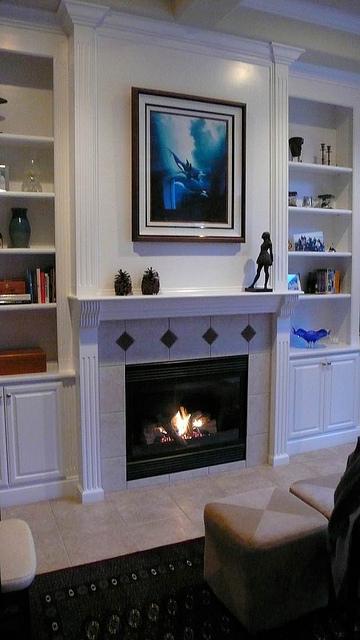Is the fireplace useable?
Answer briefly. Yes. Why are there no cabinet doors on the right side?
Concise answer only. It's shelf. Does the person who lives in this room read a lot?
Give a very brief answer. No. What is at the bottom of the picture?
Keep it brief. Rug. Is there a photo on the wall?
Write a very short answer. Yes. How many women are in the picture?
Keep it brief. 0. How many license plates are on the shelves?
Write a very short answer. 0. What kind of room is this?
Write a very short answer. Living room. What material is the fireplace made out of?
Concise answer only. Wood. Is there a lump next to the fireplace?
Short answer required. No. Who is on the poster between the bookshelves?
Concise answer only. Bird. How many red books are there?
Write a very short answer. 1. Is the fireplace lit?
Answer briefly. Yes. Where is the painting?
Give a very brief answer. Above fireplace. What is covering the window?
Be succinct. Nothing. Was someone/something resting on the ottoman?
Short answer required. No. What color is the frame around the picture?
Write a very short answer. Black. Is the fireplace on?
Quick response, please. Yes. How many pictures are on the wall?
Keep it brief. 1. What is inside of the fireplace?
Be succinct. Fire. What type of flooring is this?
Answer briefly. Tile. 